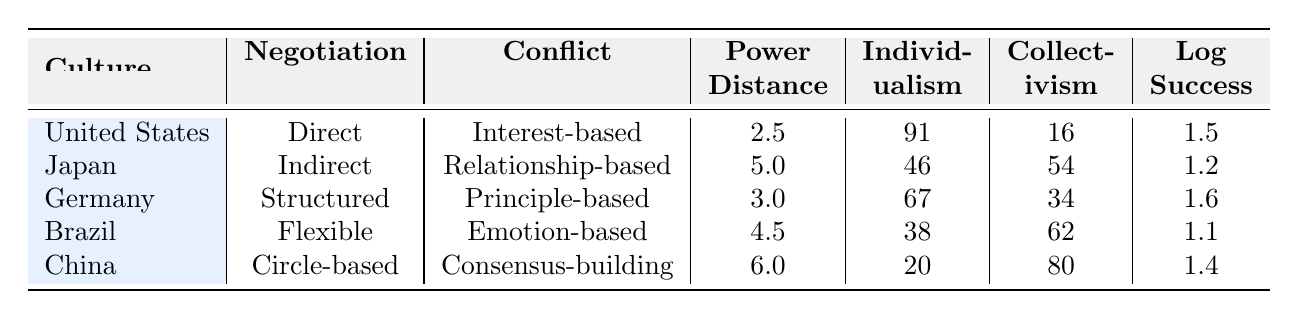What is the negotiation style of China? The negotiation style is listed directly in the row corresponding to China. Referring to that row, it states that the negotiation style for China is "Circle-based."
Answer: Circle-based Which culture has the highest level of individualism? To find the highest level of individualism, we look at the 'Individualism' column for all cultures. The values are 91, 46, 67, 38, and 20. The highest value is 91, which corresponds to the United States.
Answer: United States What is the average log negotiation outcome success for all cultures? We sum the log negotiation outcome success values: 1.5 (US) + 1.2 (Japan) + 1.6 (Germany) + 1.1 (Brazil) + 1.4 (China) = 6.8. There are 5 cultures, so we divide 6.8 by 5 to find the average: 6.8 / 5 = 1.36.
Answer: 1.36 Does Germany have a higher power distance than Brazil? Comparing the power distance values, Germany has a power distance of 3.0, and Brazil has a power distance of 4.5. Since 3.0 is less than 4.5, Germany does not have a higher power distance than Brazil.
Answer: No Which culture has a relationship-based conflict resolution style, and what is its log negotiation outcome success value? To find a culture with a relationship-based conflict resolution style, we check the 'Conflict Resolution' column. Japan corresponds to this style, and its log negotiation outcome success value is found in the same row as Japan, which is 1.2.
Answer: Japan, 1.2 What is the difference in collectivism between Brazil and China? We look at the collectivism values: Brazil has a collectivism score of 62, and China has a score of 80. To find the difference, we subtract Brazil's score from China's: 80 - 62 = 18.
Answer: 18 Is the collectivism score higher in Japan than in the United States? Japan has a collectivism score of 54, while the United States has a score of 16. Since 54 is greater than 16, Japan does indeed have a higher collectivism score than the United States.
Answer: Yes How does the negotiation outcome success of the United States compare to that of Japan? The log negotiation outcome success for the United States is 1.5, while for Japan, it is 1.2. To compare, 1.5 is greater than 1.2, indicating that the United States has a better negotiation outcome success than Japan.
Answer: United States has better outcome 